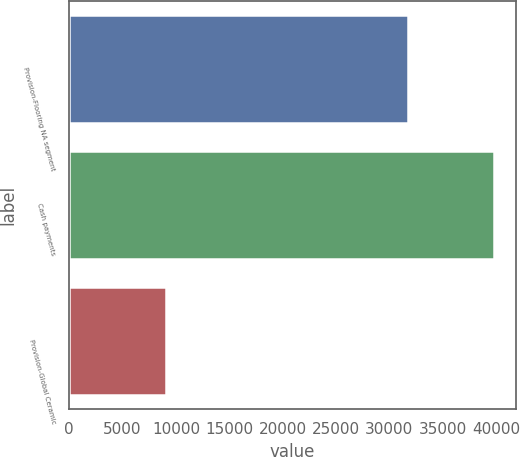<chart> <loc_0><loc_0><loc_500><loc_500><bar_chart><fcel>Provision-Flooring NA segment<fcel>Cash payments<fcel>Provision-Global Ceramic<nl><fcel>31796<fcel>39833<fcel>9109<nl></chart> 